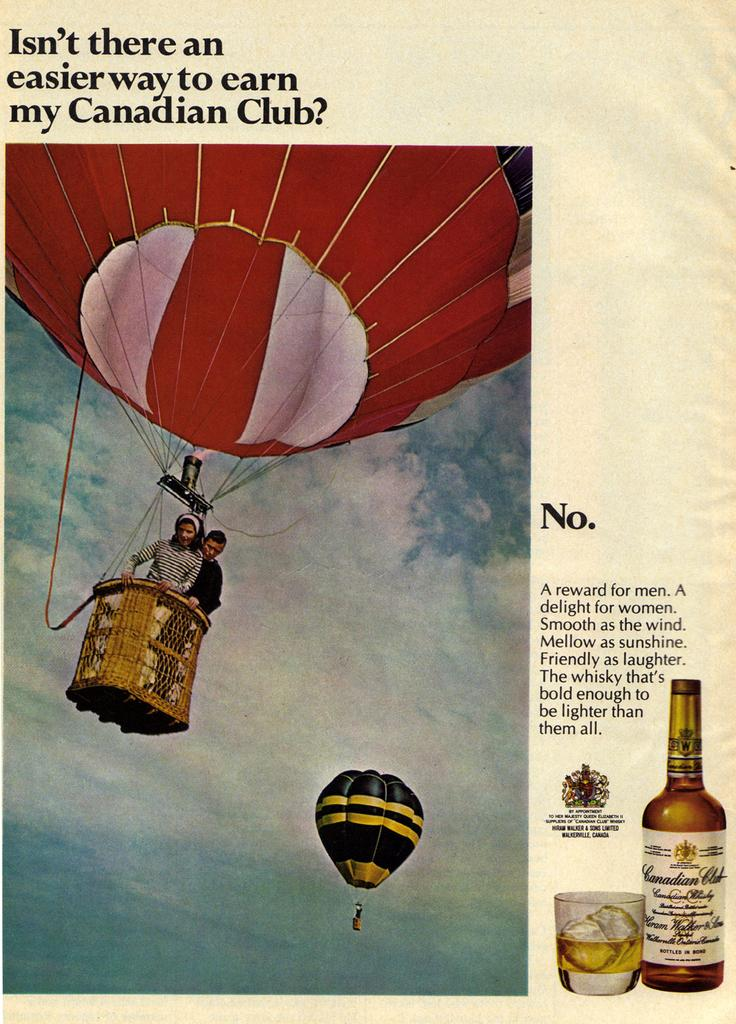Who is present in the image? There is a man and a woman in the image. What are they doing in the image? They are on a parachute. What type of image is it? It is a poster. What objects can be seen in the poster? There is a bottle, a glass, and a drink with ice cubes in the poster. What is visible in the background of the image? The sky is visible in the image, and clouds are present in the sky. What rhythm is the cloud following in the image? There is no rhythm associated with the cloud in the image, as clouds are natural phenomena and do not follow a rhythm. What type of amusement park can be seen in the image? There is no amusement park present in the image; it features a man and a woman on a parachute, a poster with various objects, and a sky with clouds. 